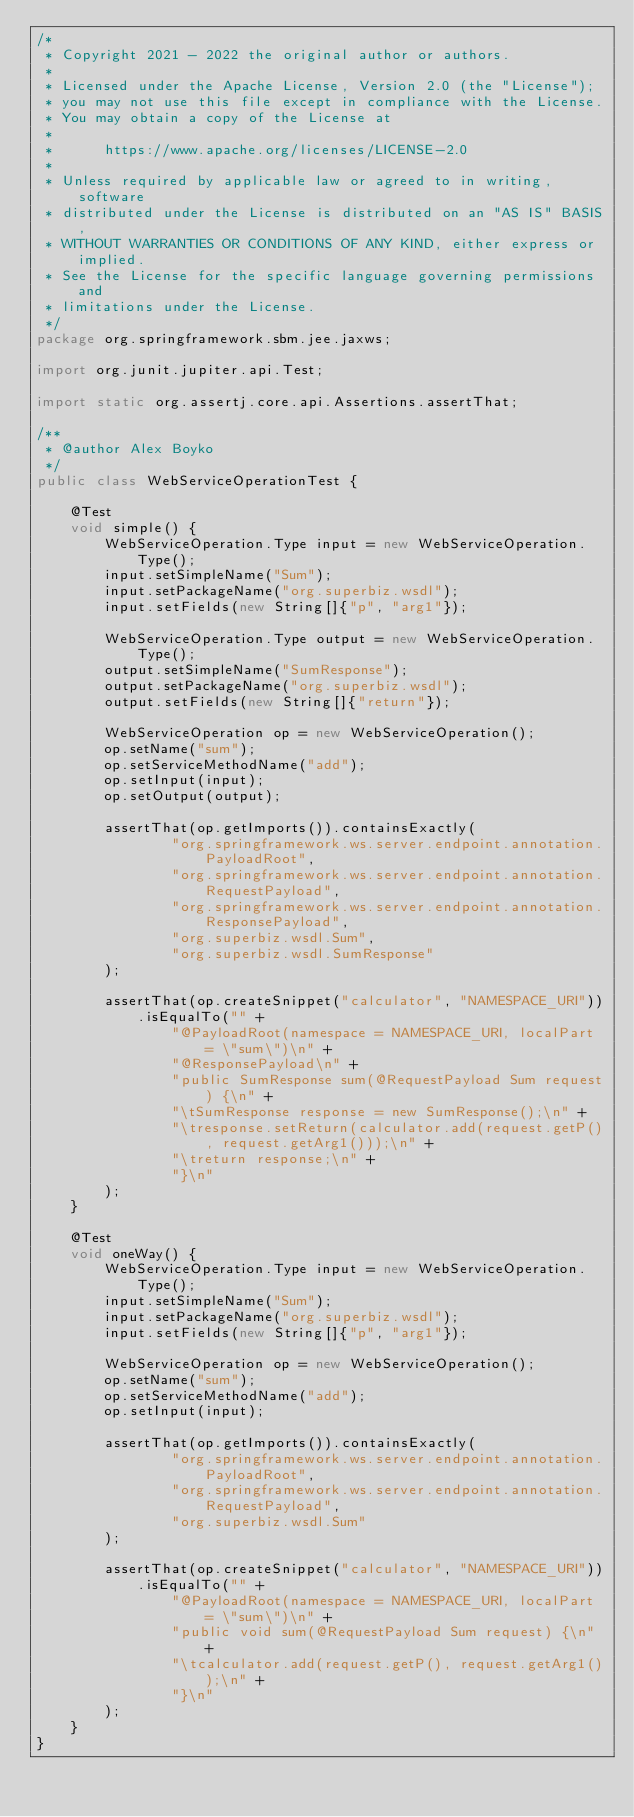Convert code to text. <code><loc_0><loc_0><loc_500><loc_500><_Java_>/*
 * Copyright 2021 - 2022 the original author or authors.
 *
 * Licensed under the Apache License, Version 2.0 (the "License");
 * you may not use this file except in compliance with the License.
 * You may obtain a copy of the License at
 *
 *      https://www.apache.org/licenses/LICENSE-2.0
 *
 * Unless required by applicable law or agreed to in writing, software
 * distributed under the License is distributed on an "AS IS" BASIS,
 * WITHOUT WARRANTIES OR CONDITIONS OF ANY KIND, either express or implied.
 * See the License for the specific language governing permissions and
 * limitations under the License.
 */
package org.springframework.sbm.jee.jaxws;

import org.junit.jupiter.api.Test;

import static org.assertj.core.api.Assertions.assertThat;

/**
 * @author Alex Boyko
 */
public class WebServiceOperationTest {

    @Test
    void simple() {
        WebServiceOperation.Type input = new WebServiceOperation.Type();
        input.setSimpleName("Sum");
        input.setPackageName("org.superbiz.wsdl");
        input.setFields(new String[]{"p", "arg1"});

        WebServiceOperation.Type output = new WebServiceOperation.Type();
        output.setSimpleName("SumResponse");
        output.setPackageName("org.superbiz.wsdl");
        output.setFields(new String[]{"return"});

        WebServiceOperation op = new WebServiceOperation();
        op.setName("sum");
        op.setServiceMethodName("add");
        op.setInput(input);
        op.setOutput(output);

        assertThat(op.getImports()).containsExactly(
                "org.springframework.ws.server.endpoint.annotation.PayloadRoot",
                "org.springframework.ws.server.endpoint.annotation.RequestPayload",
                "org.springframework.ws.server.endpoint.annotation.ResponsePayload",
                "org.superbiz.wsdl.Sum",
                "org.superbiz.wsdl.SumResponse"
        );

        assertThat(op.createSnippet("calculator", "NAMESPACE_URI")).isEqualTo("" +
                "@PayloadRoot(namespace = NAMESPACE_URI, localPart = \"sum\")\n" +
                "@ResponsePayload\n" +
                "public SumResponse sum(@RequestPayload Sum request) {\n" +
                "\tSumResponse response = new SumResponse();\n" +
                "\tresponse.setReturn(calculator.add(request.getP(), request.getArg1()));\n" +
                "\treturn response;\n" +
                "}\n"
        );
    }

    @Test
    void oneWay() {
        WebServiceOperation.Type input = new WebServiceOperation.Type();
        input.setSimpleName("Sum");
        input.setPackageName("org.superbiz.wsdl");
        input.setFields(new String[]{"p", "arg1"});

        WebServiceOperation op = new WebServiceOperation();
        op.setName("sum");
        op.setServiceMethodName("add");
        op.setInput(input);

        assertThat(op.getImports()).containsExactly(
                "org.springframework.ws.server.endpoint.annotation.PayloadRoot",
                "org.springframework.ws.server.endpoint.annotation.RequestPayload",
                "org.superbiz.wsdl.Sum"
        );

        assertThat(op.createSnippet("calculator", "NAMESPACE_URI")).isEqualTo("" +
                "@PayloadRoot(namespace = NAMESPACE_URI, localPart = \"sum\")\n" +
                "public void sum(@RequestPayload Sum request) {\n" +
                "\tcalculator.add(request.getP(), request.getArg1());\n" +
                "}\n"
        );
    }
}
</code> 